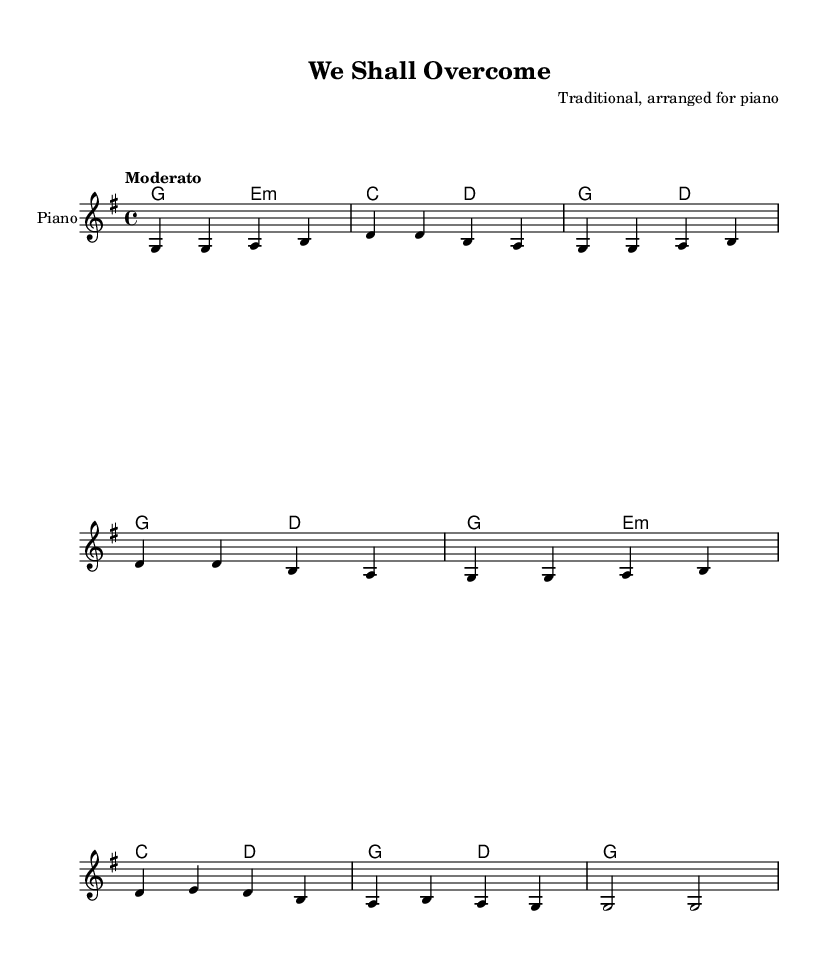What is the key signature of this music? The key signature is indicated at the beginning of the music sheet, showing one sharp, which corresponds to G major.
Answer: G major What is the time signature of this piece? The time signature is found at the beginning of the score, which shows four beats per measure, represented as 4/4.
Answer: 4/4 What is the tempo marking of this song? The tempo marking appears just above the melody staff, indicating a moderate pace for the piece to be played.
Answer: Moderato How many measures are in the melody? By counting the sections separated by vertical lines on the sheet music, there are a total of eight measures in the melody section.
Answer: 8 What are the first two notes of the melody? The first two notes of the melody can be found at the very beginning of the staff, where the notes G and G are indicated.
Answer: G, G What chord follows the first measure? The chord symbol following the first measure is shown directly above the melody notes, indicating an E minor chord is played next.
Answer: E minor How many times is the note G repeated in the melody? By analyzing the melody line, the note G appears seven times throughout the melody.
Answer: 7 